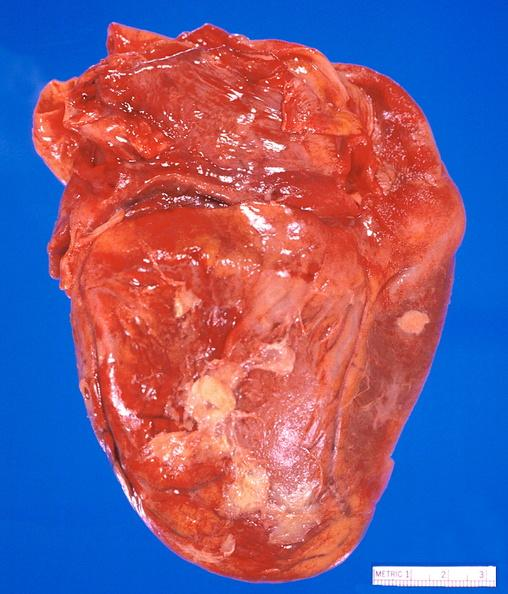what does this image show?
Answer the question using a single word or phrase. Heart 